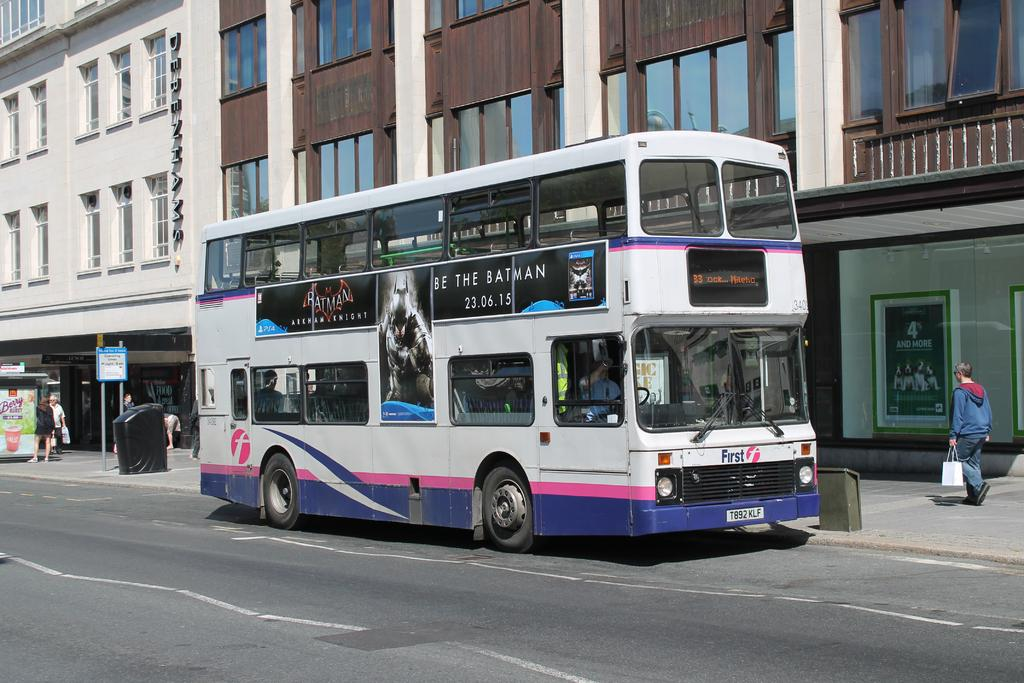<image>
Render a clear and concise summary of the photo. A bus advertises the movie batman releasing on 23.06.15. 